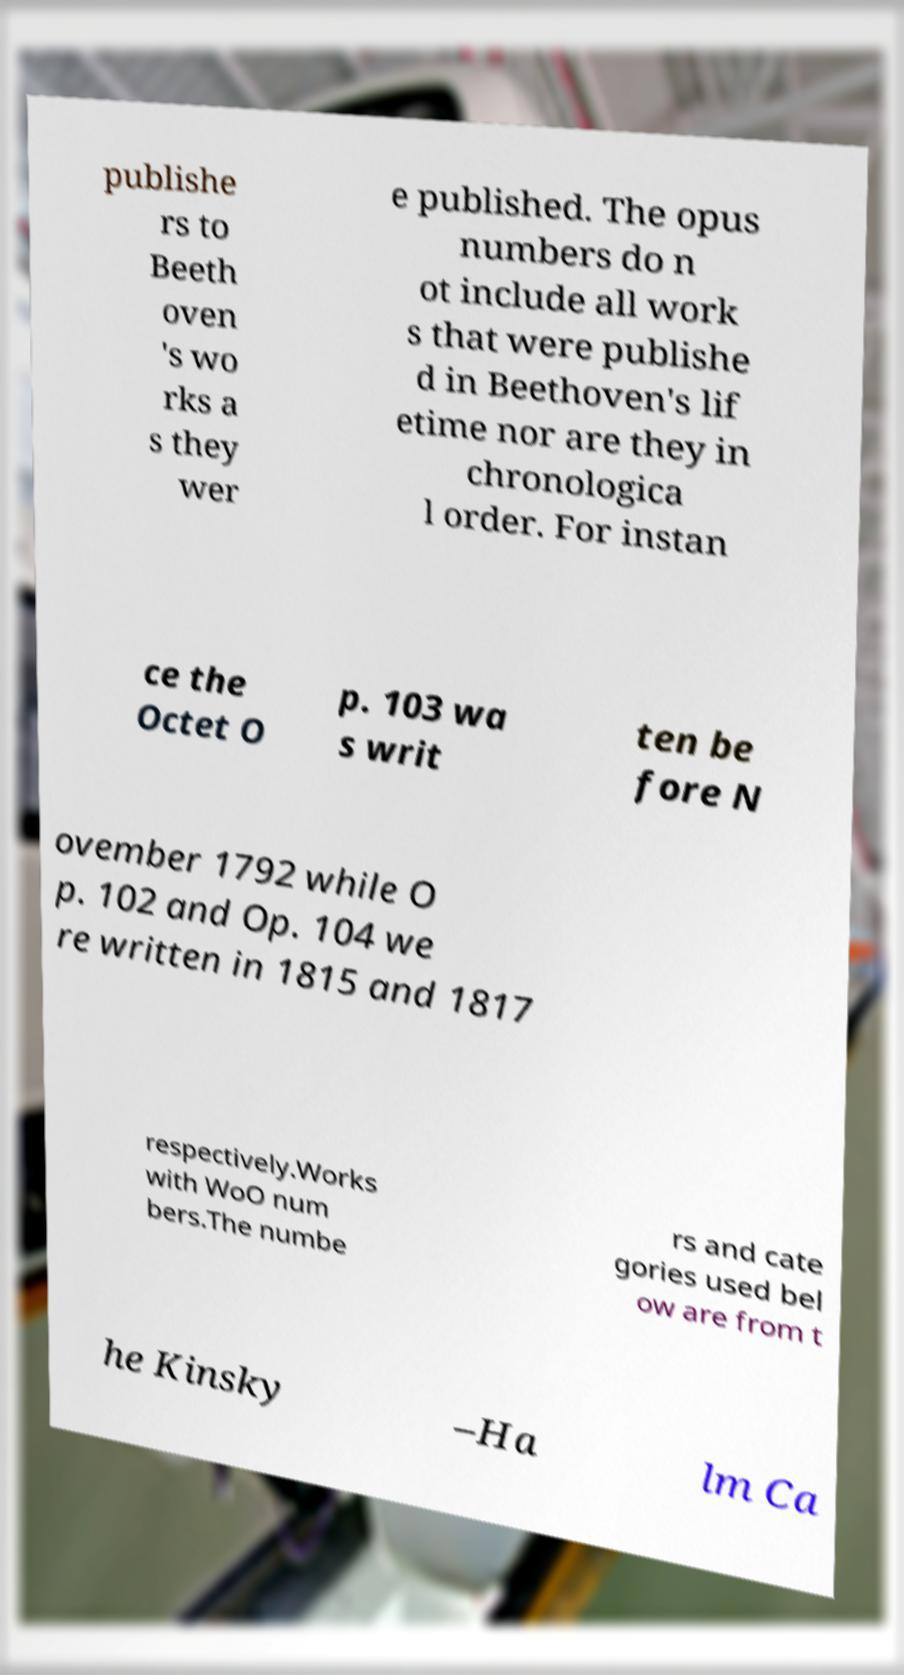For documentation purposes, I need the text within this image transcribed. Could you provide that? publishe rs to Beeth oven 's wo rks a s they wer e published. The opus numbers do n ot include all work s that were publishe d in Beethoven's lif etime nor are they in chronologica l order. For instan ce the Octet O p. 103 wa s writ ten be fore N ovember 1792 while O p. 102 and Op. 104 we re written in 1815 and 1817 respectively.Works with WoO num bers.The numbe rs and cate gories used bel ow are from t he Kinsky –Ha lm Ca 